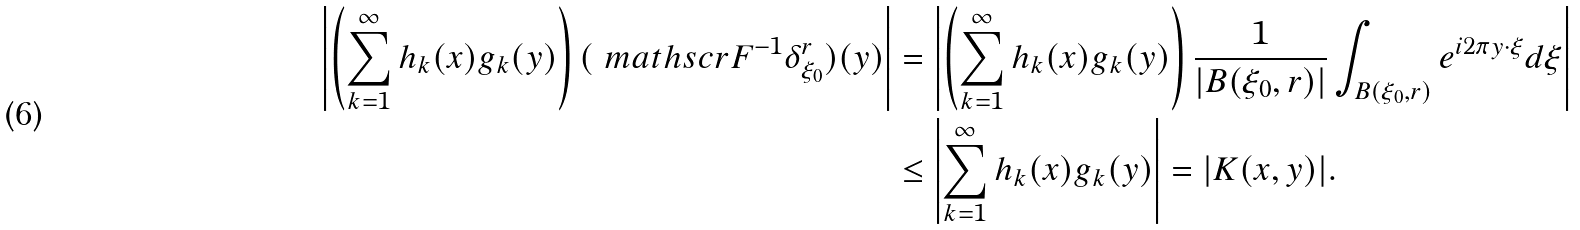Convert formula to latex. <formula><loc_0><loc_0><loc_500><loc_500>\left | \left ( \sum _ { k = 1 } ^ { \infty } h _ { k } ( x ) g _ { k } ( y ) \right ) ( \ m a t h s c r { F } ^ { - 1 } \delta _ { \xi _ { 0 } } ^ { r } ) ( y ) \right | & = \left | \left ( \sum _ { k = 1 } ^ { \infty } h _ { k } ( x ) g _ { k } ( y ) \right ) \frac { 1 } { | B ( \xi _ { 0 } , r ) | } \int _ { B ( \xi _ { 0 } , r ) } e ^ { i 2 \pi y \cdot \xi } d \xi \right | \\ & \leq \left | \sum _ { k = 1 } ^ { \infty } h _ { k } ( x ) g _ { k } ( y ) \right | = | K ( x , y ) | .</formula> 